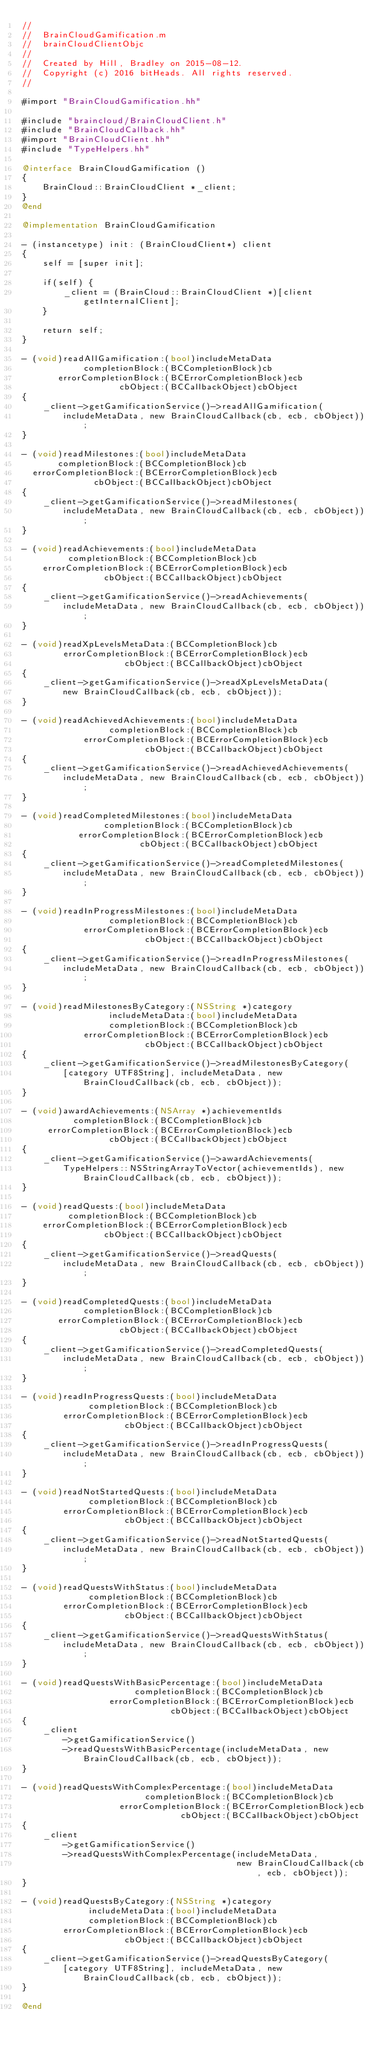Convert code to text. <code><loc_0><loc_0><loc_500><loc_500><_ObjectiveC_>//
//  BrainCloudGamification.m
//  brainCloudClientObjc
//
//  Created by Hill, Bradley on 2015-08-12.
//  Copyright (c) 2016 bitHeads. All rights reserved.
//

#import "BrainCloudGamification.hh"

#include "braincloud/BrainCloudClient.h"
#include "BrainCloudCallback.hh"
#import "BrainCloudClient.hh"
#include "TypeHelpers.hh"

@interface BrainCloudGamification ()
{
    BrainCloud::BrainCloudClient *_client;
}
@end

@implementation BrainCloudGamification

- (instancetype) init: (BrainCloudClient*) client
{
    self = [super init];

    if(self) {
        _client = (BrainCloud::BrainCloudClient *)[client getInternalClient];
    }

    return self;
}

- (void)readAllGamification:(bool)includeMetaData
            completionBlock:(BCCompletionBlock)cb
       errorCompletionBlock:(BCErrorCompletionBlock)ecb
                   cbObject:(BCCallbackObject)cbObject
{
    _client->getGamificationService()->readAllGamification(
        includeMetaData, new BrainCloudCallback(cb, ecb, cbObject));
}

- (void)readMilestones:(bool)includeMetaData
       completionBlock:(BCCompletionBlock)cb
  errorCompletionBlock:(BCErrorCompletionBlock)ecb
              cbObject:(BCCallbackObject)cbObject
{
    _client->getGamificationService()->readMilestones(
        includeMetaData, new BrainCloudCallback(cb, ecb, cbObject));
}

- (void)readAchievements:(bool)includeMetaData
         completionBlock:(BCCompletionBlock)cb
    errorCompletionBlock:(BCErrorCompletionBlock)ecb
                cbObject:(BCCallbackObject)cbObject
{
    _client->getGamificationService()->readAchievements(
        includeMetaData, new BrainCloudCallback(cb, ecb, cbObject));
}

- (void)readXpLevelsMetaData:(BCCompletionBlock)cb
        errorCompletionBlock:(BCErrorCompletionBlock)ecb
                    cbObject:(BCCallbackObject)cbObject
{
    _client->getGamificationService()->readXpLevelsMetaData(
        new BrainCloudCallback(cb, ecb, cbObject));
}

- (void)readAchievedAchievements:(bool)includeMetaData
                 completionBlock:(BCCompletionBlock)cb
            errorCompletionBlock:(BCErrorCompletionBlock)ecb
                        cbObject:(BCCallbackObject)cbObject
{
    _client->getGamificationService()->readAchievedAchievements(
        includeMetaData, new BrainCloudCallback(cb, ecb, cbObject));
}

- (void)readCompletedMilestones:(bool)includeMetaData
                completionBlock:(BCCompletionBlock)cb
           errorCompletionBlock:(BCErrorCompletionBlock)ecb
                       cbObject:(BCCallbackObject)cbObject
{
    _client->getGamificationService()->readCompletedMilestones(
        includeMetaData, new BrainCloudCallback(cb, ecb, cbObject));
}

- (void)readInProgressMilestones:(bool)includeMetaData
                 completionBlock:(BCCompletionBlock)cb
            errorCompletionBlock:(BCErrorCompletionBlock)ecb
                        cbObject:(BCCallbackObject)cbObject
{
    _client->getGamificationService()->readInProgressMilestones(
        includeMetaData, new BrainCloudCallback(cb, ecb, cbObject));
}

- (void)readMilestonesByCategory:(NSString *)category
                 includeMetaData:(bool)includeMetaData
                 completionBlock:(BCCompletionBlock)cb
            errorCompletionBlock:(BCErrorCompletionBlock)ecb
                        cbObject:(BCCallbackObject)cbObject
{
    _client->getGamificationService()->readMilestonesByCategory(
        [category UTF8String], includeMetaData, new BrainCloudCallback(cb, ecb, cbObject));
}

- (void)awardAchievements:(NSArray *)achievementIds
          completionBlock:(BCCompletionBlock)cb
     errorCompletionBlock:(BCErrorCompletionBlock)ecb
                 cbObject:(BCCallbackObject)cbObject
{
    _client->getGamificationService()->awardAchievements(
        TypeHelpers::NSStringArrayToVector(achievementIds), new BrainCloudCallback(cb, ecb, cbObject));
}

- (void)readQuests:(bool)includeMetaData
         completionBlock:(BCCompletionBlock)cb
    errorCompletionBlock:(BCErrorCompletionBlock)ecb
                cbObject:(BCCallbackObject)cbObject
{
    _client->getGamificationService()->readQuests(
        includeMetaData, new BrainCloudCallback(cb, ecb, cbObject));
}

- (void)readCompletedQuests:(bool)includeMetaData
            completionBlock:(BCCompletionBlock)cb
       errorCompletionBlock:(BCErrorCompletionBlock)ecb
                   cbObject:(BCCallbackObject)cbObject
{
    _client->getGamificationService()->readCompletedQuests(
        includeMetaData, new BrainCloudCallback(cb, ecb, cbObject));
}

- (void)readInProgressQuests:(bool)includeMetaData
             completionBlock:(BCCompletionBlock)cb
        errorCompletionBlock:(BCErrorCompletionBlock)ecb
                    cbObject:(BCCallbackObject)cbObject
{
    _client->getGamificationService()->readInProgressQuests(
        includeMetaData, new BrainCloudCallback(cb, ecb, cbObject));
}

- (void)readNotStartedQuests:(bool)includeMetaData
             completionBlock:(BCCompletionBlock)cb
        errorCompletionBlock:(BCErrorCompletionBlock)ecb
                    cbObject:(BCCallbackObject)cbObject
{
    _client->getGamificationService()->readNotStartedQuests(
        includeMetaData, new BrainCloudCallback(cb, ecb, cbObject));
}

- (void)readQuestsWithStatus:(bool)includeMetaData
             completionBlock:(BCCompletionBlock)cb
        errorCompletionBlock:(BCErrorCompletionBlock)ecb
                    cbObject:(BCCallbackObject)cbObject
{
    _client->getGamificationService()->readQuestsWithStatus(
        includeMetaData, new BrainCloudCallback(cb, ecb, cbObject));
}

- (void)readQuestsWithBasicPercentage:(bool)includeMetaData
                      completionBlock:(BCCompletionBlock)cb
                 errorCompletionBlock:(BCErrorCompletionBlock)ecb
                             cbObject:(BCCallbackObject)cbObject
{
    _client
        ->getGamificationService()
        ->readQuestsWithBasicPercentage(includeMetaData, new BrainCloudCallback(cb, ecb, cbObject));
}

- (void)readQuestsWithComplexPercentage:(bool)includeMetaData
                        completionBlock:(BCCompletionBlock)cb
                   errorCompletionBlock:(BCErrorCompletionBlock)ecb
                               cbObject:(BCCallbackObject)cbObject
{
    _client
        ->getGamificationService()
        ->readQuestsWithComplexPercentage(includeMetaData,
                                          new BrainCloudCallback(cb, ecb, cbObject));
}

- (void)readQuestsByCategory:(NSString *)category
             includeMetaData:(bool)includeMetaData
             completionBlock:(BCCompletionBlock)cb
        errorCompletionBlock:(BCErrorCompletionBlock)ecb
                    cbObject:(BCCallbackObject)cbObject
{
    _client->getGamificationService()->readQuestsByCategory(
        [category UTF8String], includeMetaData, new BrainCloudCallback(cb, ecb, cbObject));
}

@end
</code> 